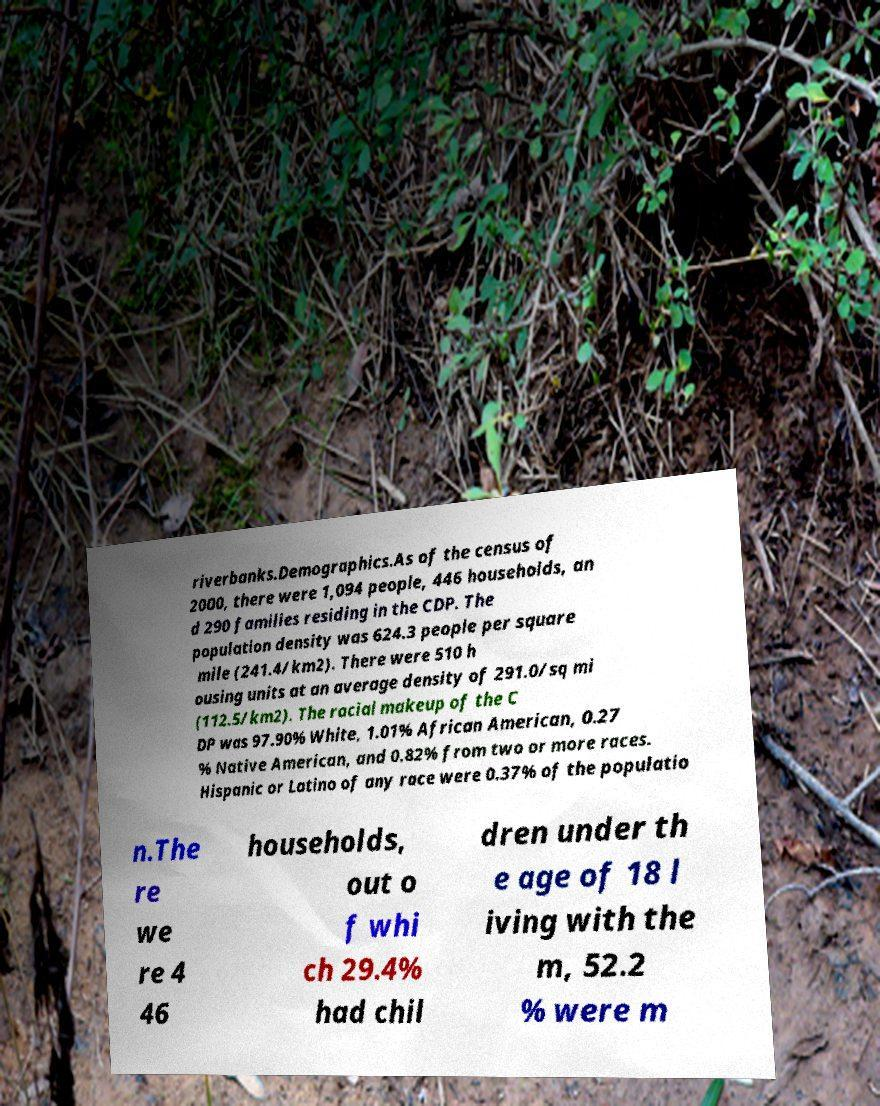Please identify and transcribe the text found in this image. riverbanks.Demographics.As of the census of 2000, there were 1,094 people, 446 households, an d 290 families residing in the CDP. The population density was 624.3 people per square mile (241.4/km2). There were 510 h ousing units at an average density of 291.0/sq mi (112.5/km2). The racial makeup of the C DP was 97.90% White, 1.01% African American, 0.27 % Native American, and 0.82% from two or more races. Hispanic or Latino of any race were 0.37% of the populatio n.The re we re 4 46 households, out o f whi ch 29.4% had chil dren under th e age of 18 l iving with the m, 52.2 % were m 